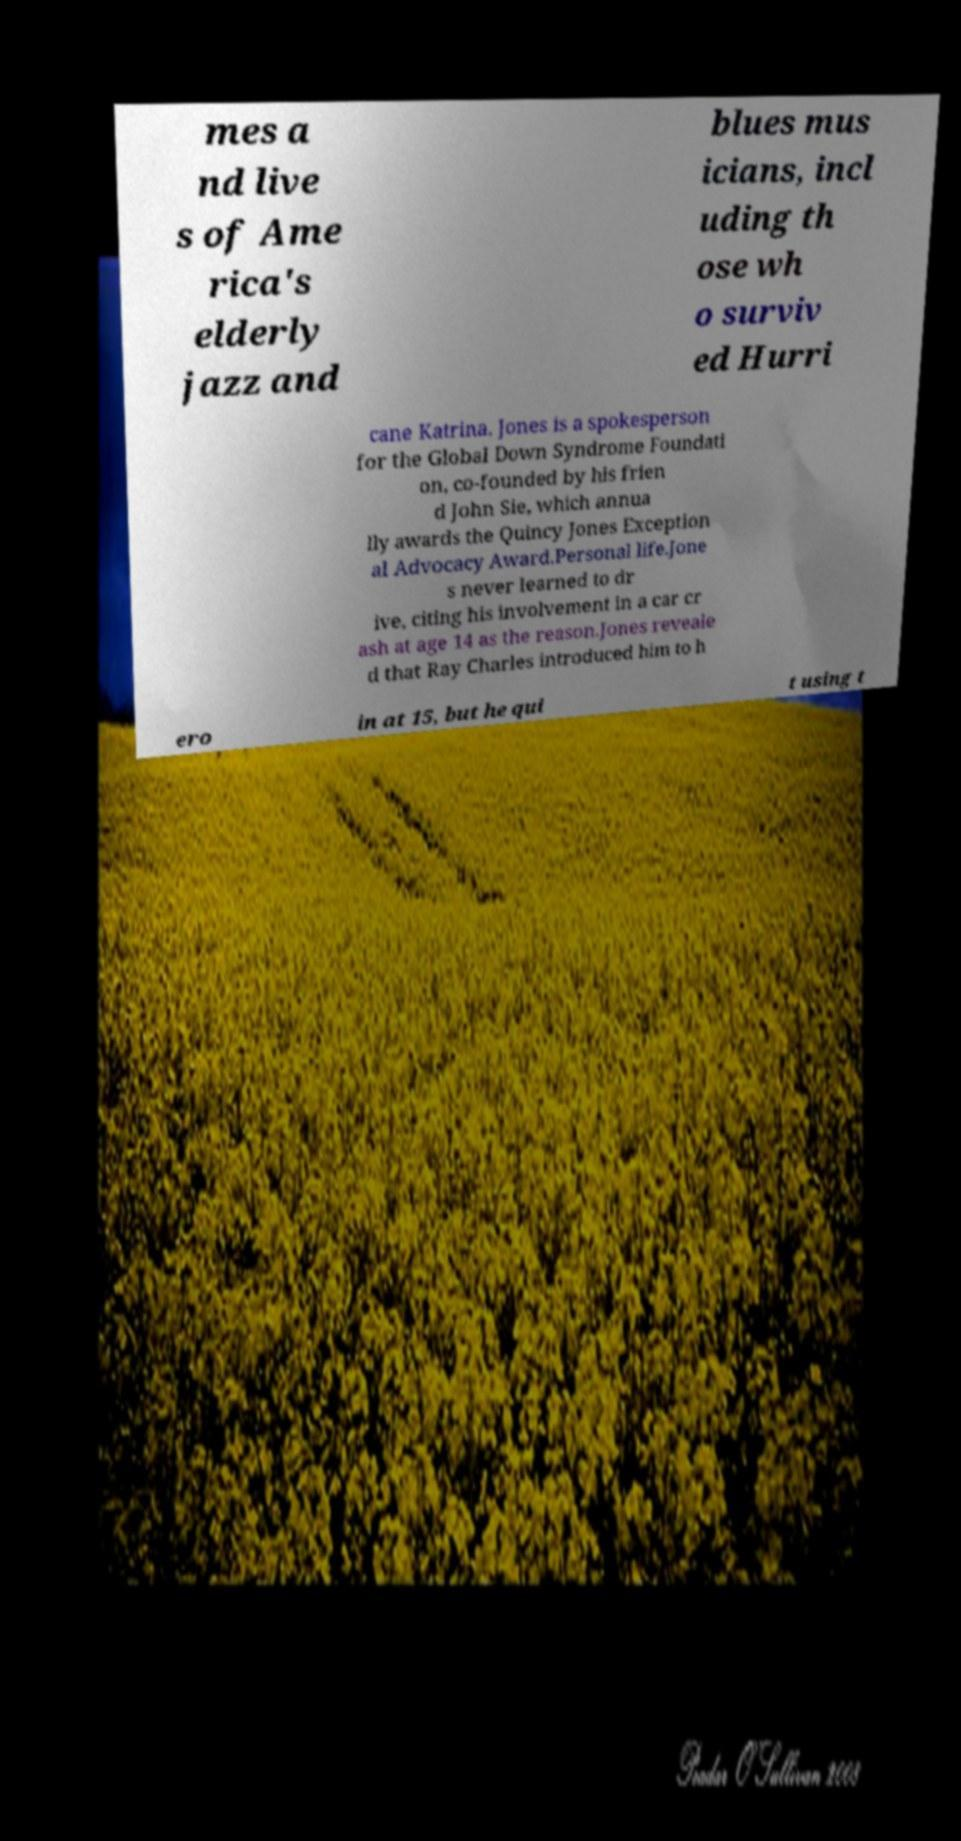Please read and relay the text visible in this image. What does it say? mes a nd live s of Ame rica's elderly jazz and blues mus icians, incl uding th ose wh o surviv ed Hurri cane Katrina. Jones is a spokesperson for the Global Down Syndrome Foundati on, co-founded by his frien d John Sie, which annua lly awards the Quincy Jones Exception al Advocacy Award.Personal life.Jone s never learned to dr ive, citing his involvement in a car cr ash at age 14 as the reason.Jones reveale d that Ray Charles introduced him to h ero in at 15, but he qui t using t 